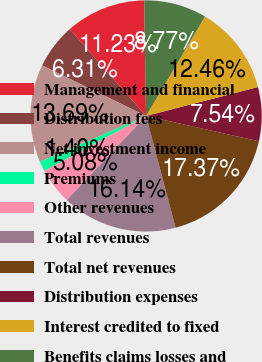<chart> <loc_0><loc_0><loc_500><loc_500><pie_chart><fcel>Management and financial<fcel>Distribution fees<fcel>Net investment income<fcel>Premiums<fcel>Other revenues<fcel>Total revenues<fcel>Total net revenues<fcel>Distribution expenses<fcel>Interest credited to fixed<fcel>Benefits claims losses and<nl><fcel>11.23%<fcel>6.31%<fcel>13.69%<fcel>1.4%<fcel>5.08%<fcel>16.14%<fcel>17.37%<fcel>7.54%<fcel>12.46%<fcel>8.77%<nl></chart> 